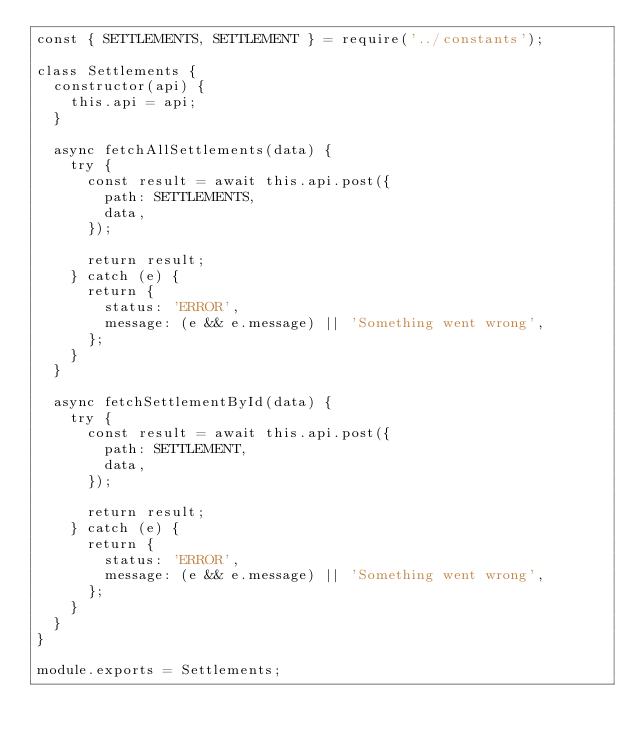Convert code to text. <code><loc_0><loc_0><loc_500><loc_500><_JavaScript_>const { SETTLEMENTS, SETTLEMENT } = require('../constants');

class Settlements {
  constructor(api) {
    this.api = api;
  }

  async fetchAllSettlements(data) {
    try {
      const result = await this.api.post({
        path: SETTLEMENTS,
        data,
      });

      return result;
    } catch (e) {
      return {
        status: 'ERROR',
        message: (e && e.message) || 'Something went wrong',
      };
    }
  }

  async fetchSettlementById(data) {
    try {
      const result = await this.api.post({
        path: SETTLEMENT,
        data,
      });

      return result;
    } catch (e) {
      return {
        status: 'ERROR',
        message: (e && e.message) || 'Something went wrong',
      };
    }
  }
}

module.exports = Settlements;
</code> 